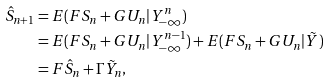Convert formula to latex. <formula><loc_0><loc_0><loc_500><loc_500>\hat { S } _ { n + 1 } & = E ( F S _ { n } + G U _ { n } | Y _ { - \infty } ^ { n } ) \\ & = E ( F S _ { n } + G U _ { n } | Y _ { - \infty } ^ { n - 1 } ) + E ( F S _ { n } + G U _ { n } | \tilde { Y } ) \\ & = F \hat { S } _ { n } + \Gamma \tilde { Y } _ { n } ,</formula> 